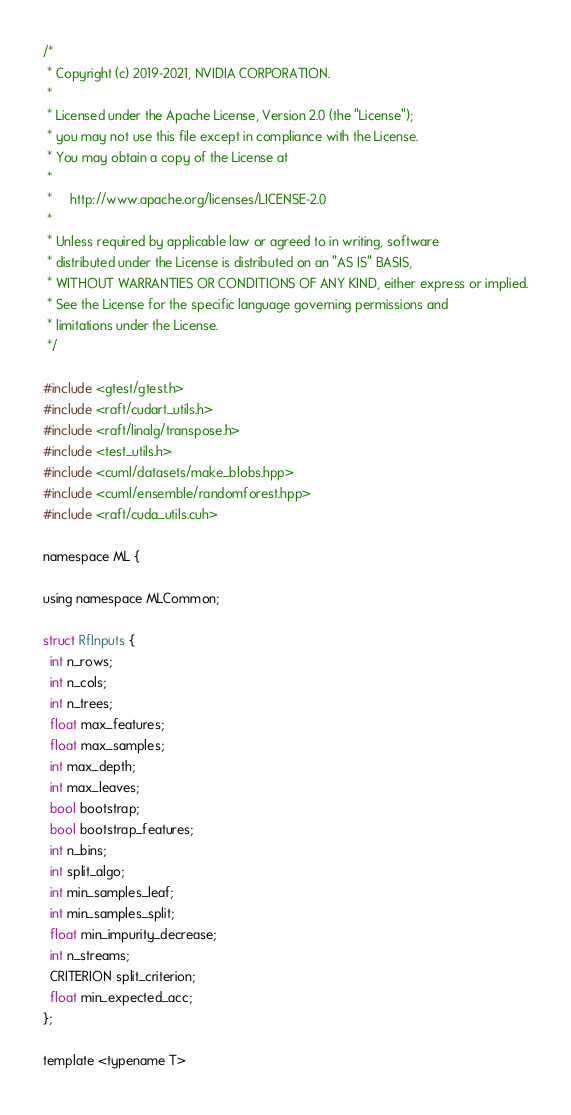<code> <loc_0><loc_0><loc_500><loc_500><_Cuda_>/*
 * Copyright (c) 2019-2021, NVIDIA CORPORATION.
 *
 * Licensed under the Apache License, Version 2.0 (the "License");
 * you may not use this file except in compliance with the License.
 * You may obtain a copy of the License at
 *
 *     http://www.apache.org/licenses/LICENSE-2.0
 *
 * Unless required by applicable law or agreed to in writing, software
 * distributed under the License is distributed on an "AS IS" BASIS,
 * WITHOUT WARRANTIES OR CONDITIONS OF ANY KIND, either express or implied.
 * See the License for the specific language governing permissions and
 * limitations under the License.
 */

#include <gtest/gtest.h>
#include <raft/cudart_utils.h>
#include <raft/linalg/transpose.h>
#include <test_utils.h>
#include <cuml/datasets/make_blobs.hpp>
#include <cuml/ensemble/randomforest.hpp>
#include <raft/cuda_utils.cuh>

namespace ML {

using namespace MLCommon;

struct RfInputs {
  int n_rows;
  int n_cols;
  int n_trees;
  float max_features;
  float max_samples;
  int max_depth;
  int max_leaves;
  bool bootstrap;
  bool bootstrap_features;
  int n_bins;
  int split_algo;
  int min_samples_leaf;
  int min_samples_split;
  float min_impurity_decrease;
  int n_streams;
  CRITERION split_criterion;
  float min_expected_acc;
};

template <typename T></code> 